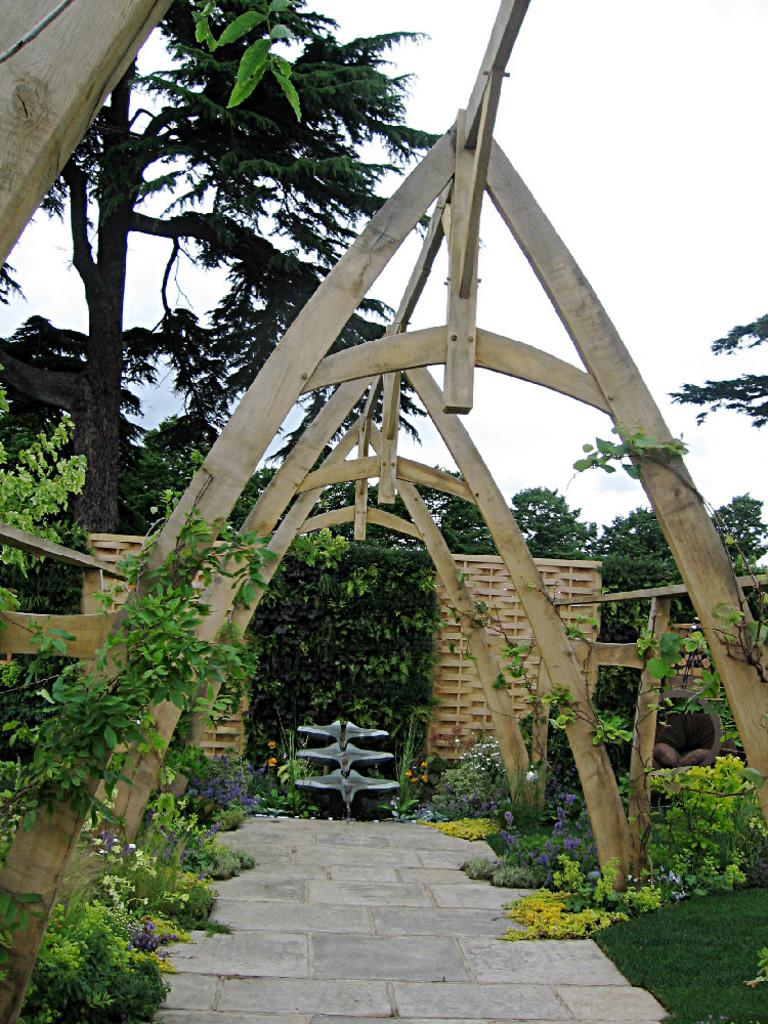What type of structure can be seen in the image? There is an architectural structure in the image. What other elements are present in the image besides the structure? There are plants and trees in the image. What is visible at the top of the image? The sky is visible at the top of the image. What type of winter clothing is visible on the branches of the trees in the image? There is no winter clothing present in the image, as it only features an architectural structure, plants, trees, and the sky. 